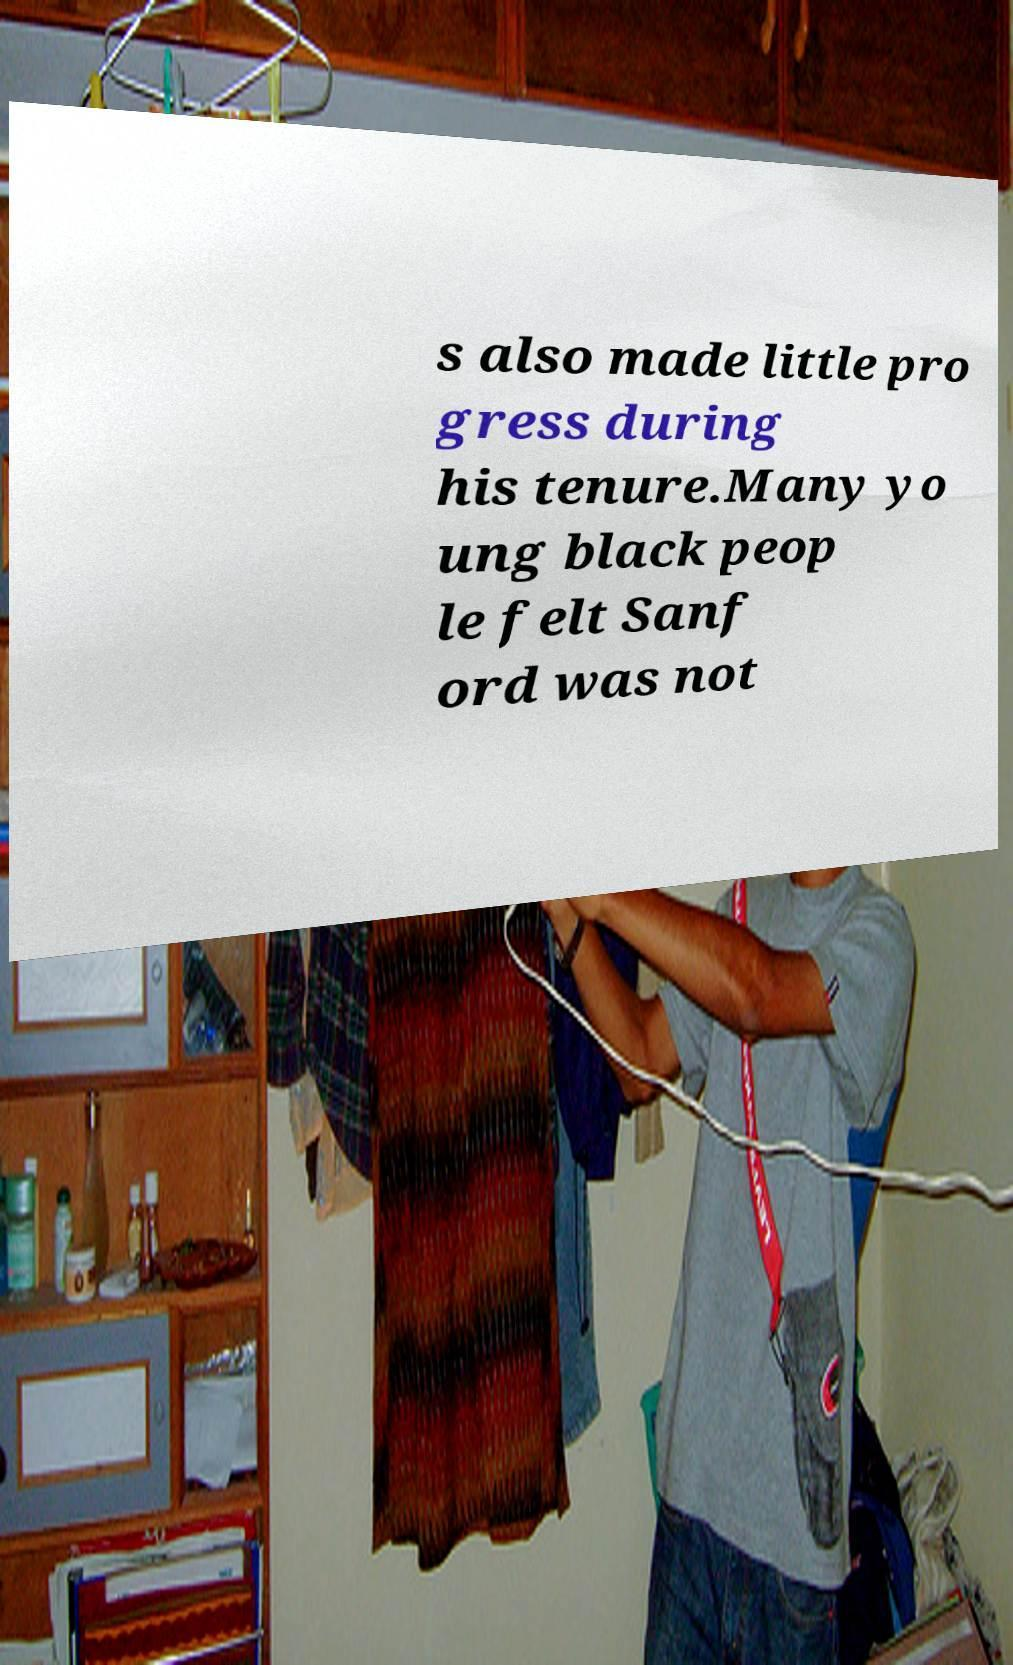Could you assist in decoding the text presented in this image and type it out clearly? s also made little pro gress during his tenure.Many yo ung black peop le felt Sanf ord was not 